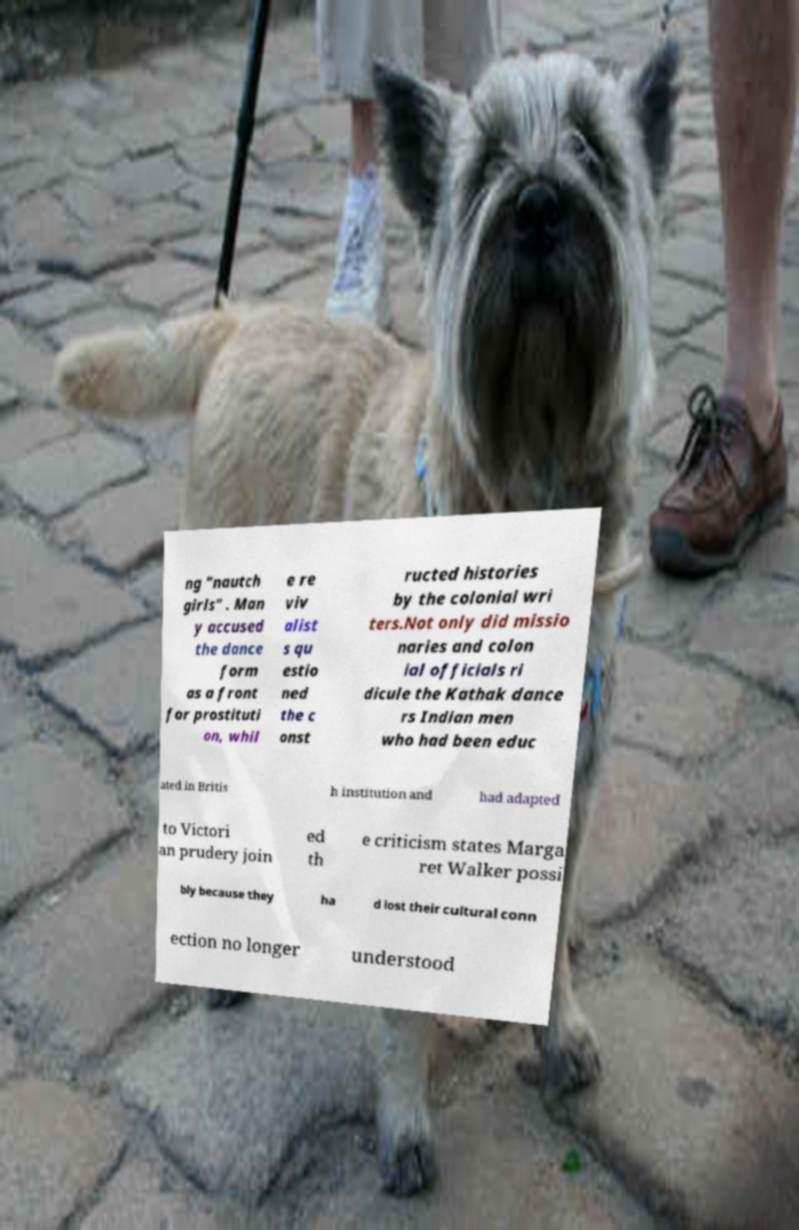I need the written content from this picture converted into text. Can you do that? ng "nautch girls" . Man y accused the dance form as a front for prostituti on, whil e re viv alist s qu estio ned the c onst ructed histories by the colonial wri ters.Not only did missio naries and colon ial officials ri dicule the Kathak dance rs Indian men who had been educ ated in Britis h institution and had adapted to Victori an prudery join ed th e criticism states Marga ret Walker possi bly because they ha d lost their cultural conn ection no longer understood 